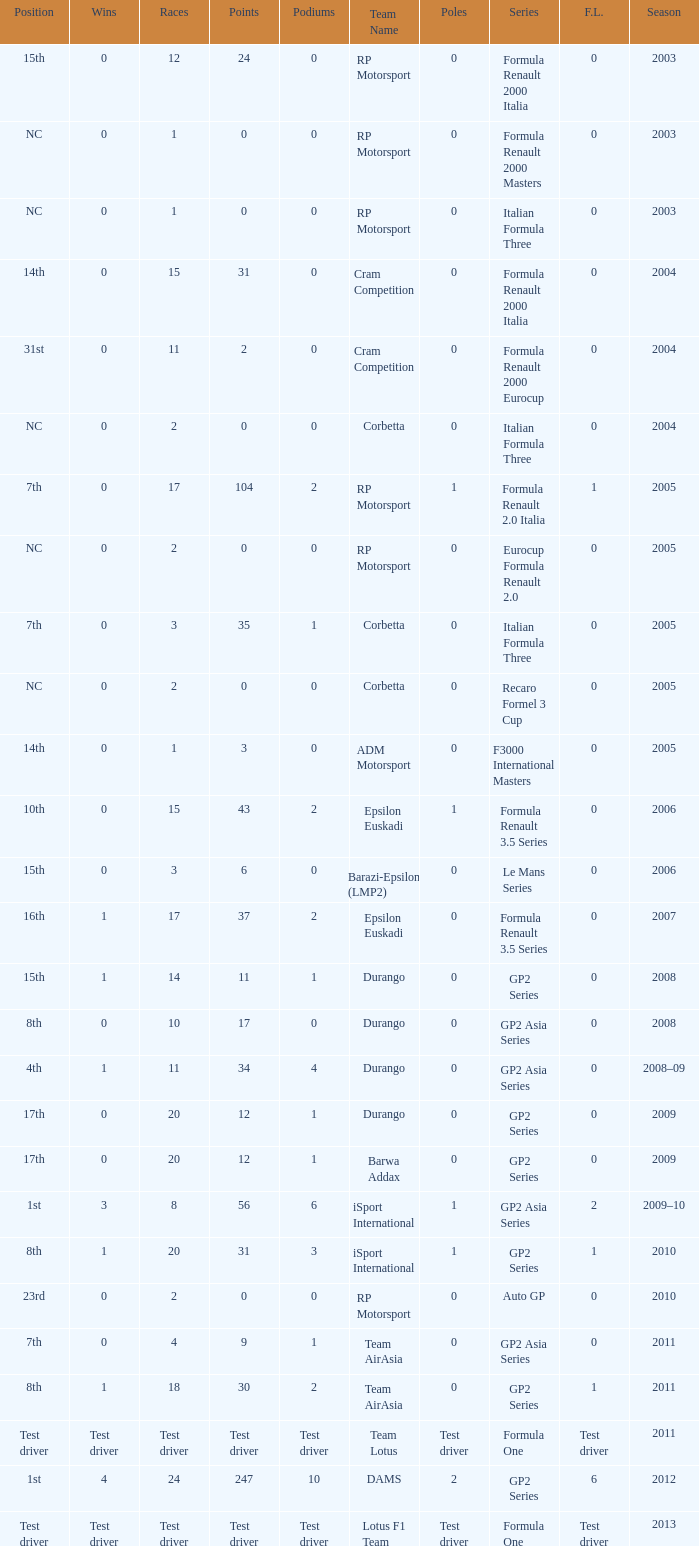What is the number of wins with a 0 F.L., 0 poles, a position of 7th, and 35 points? 0.0. 